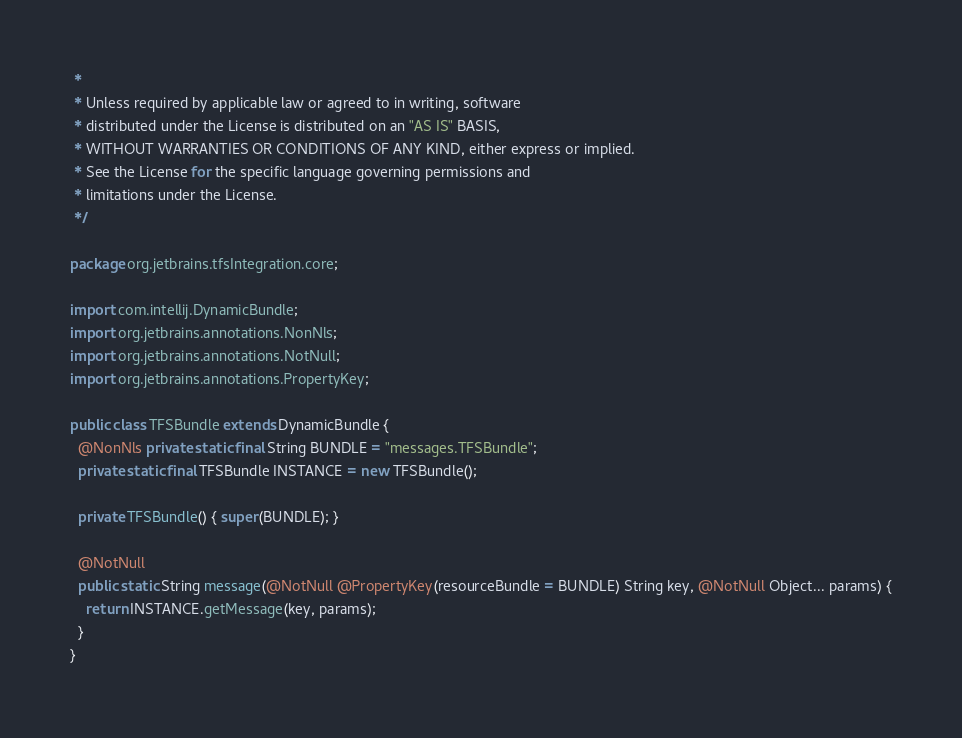Convert code to text. <code><loc_0><loc_0><loc_500><loc_500><_Java_> *
 * Unless required by applicable law or agreed to in writing, software
 * distributed under the License is distributed on an "AS IS" BASIS,
 * WITHOUT WARRANTIES OR CONDITIONS OF ANY KIND, either express or implied.
 * See the License for the specific language governing permissions and
 * limitations under the License.
 */

package org.jetbrains.tfsIntegration.core;

import com.intellij.DynamicBundle;
import org.jetbrains.annotations.NonNls;
import org.jetbrains.annotations.NotNull;
import org.jetbrains.annotations.PropertyKey;

public class TFSBundle extends DynamicBundle {
  @NonNls private static final String BUNDLE = "messages.TFSBundle";
  private static final TFSBundle INSTANCE = new TFSBundle();

  private TFSBundle() { super(BUNDLE); }

  @NotNull
  public static String message(@NotNull @PropertyKey(resourceBundle = BUNDLE) String key, @NotNull Object... params) {
    return INSTANCE.getMessage(key, params);
  }
}
</code> 